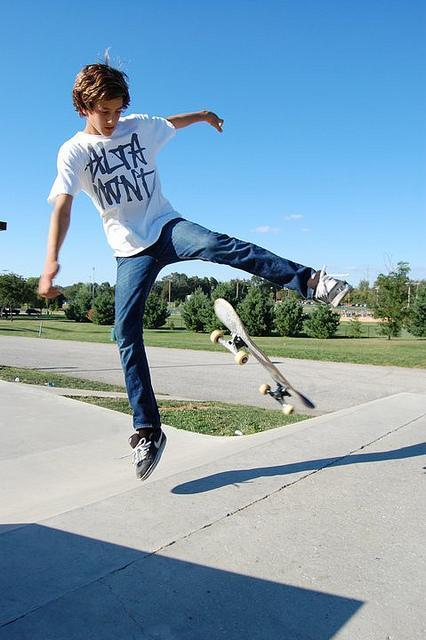How many people are wearing an orange shirt?
Give a very brief answer. 0. 